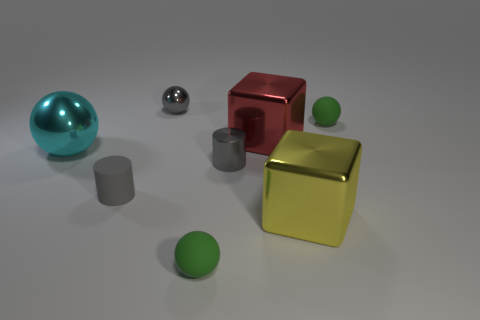Subtract all red spheres. Subtract all cyan cylinders. How many spheres are left? 4 Add 1 large yellow metallic cubes. How many objects exist? 9 Subtract all cylinders. How many objects are left? 6 Add 3 shiny cubes. How many shiny cubes exist? 5 Subtract 1 red blocks. How many objects are left? 7 Subtract all red objects. Subtract all big yellow metal cubes. How many objects are left? 6 Add 8 big blocks. How many big blocks are left? 10 